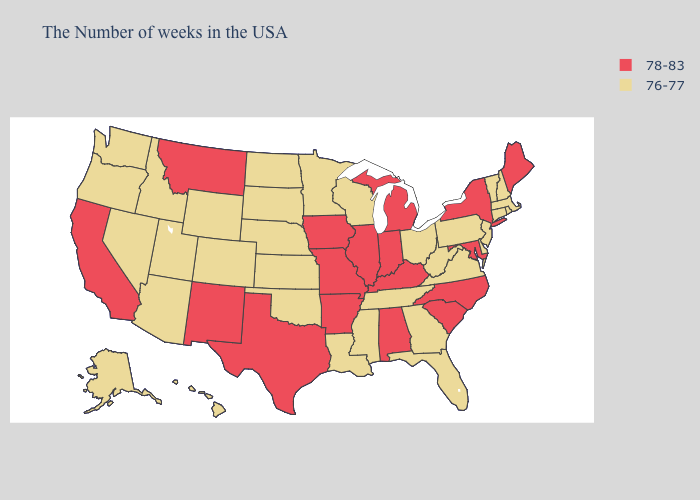Does the first symbol in the legend represent the smallest category?
Be succinct. No. Name the states that have a value in the range 78-83?
Quick response, please. Maine, New York, Maryland, North Carolina, South Carolina, Michigan, Kentucky, Indiana, Alabama, Illinois, Missouri, Arkansas, Iowa, Texas, New Mexico, Montana, California. Which states have the highest value in the USA?
Answer briefly. Maine, New York, Maryland, North Carolina, South Carolina, Michigan, Kentucky, Indiana, Alabama, Illinois, Missouri, Arkansas, Iowa, Texas, New Mexico, Montana, California. What is the lowest value in states that border Mississippi?
Write a very short answer. 76-77. Name the states that have a value in the range 76-77?
Write a very short answer. Massachusetts, Rhode Island, New Hampshire, Vermont, Connecticut, New Jersey, Delaware, Pennsylvania, Virginia, West Virginia, Ohio, Florida, Georgia, Tennessee, Wisconsin, Mississippi, Louisiana, Minnesota, Kansas, Nebraska, Oklahoma, South Dakota, North Dakota, Wyoming, Colorado, Utah, Arizona, Idaho, Nevada, Washington, Oregon, Alaska, Hawaii. What is the value of Kentucky?
Quick response, please. 78-83. What is the highest value in states that border Iowa?
Answer briefly. 78-83. Name the states that have a value in the range 78-83?
Be succinct. Maine, New York, Maryland, North Carolina, South Carolina, Michigan, Kentucky, Indiana, Alabama, Illinois, Missouri, Arkansas, Iowa, Texas, New Mexico, Montana, California. Does Michigan have the lowest value in the USA?
Concise answer only. No. Name the states that have a value in the range 78-83?
Short answer required. Maine, New York, Maryland, North Carolina, South Carolina, Michigan, Kentucky, Indiana, Alabama, Illinois, Missouri, Arkansas, Iowa, Texas, New Mexico, Montana, California. Does Massachusetts have a lower value than Indiana?
Give a very brief answer. Yes. Which states have the lowest value in the USA?
Answer briefly. Massachusetts, Rhode Island, New Hampshire, Vermont, Connecticut, New Jersey, Delaware, Pennsylvania, Virginia, West Virginia, Ohio, Florida, Georgia, Tennessee, Wisconsin, Mississippi, Louisiana, Minnesota, Kansas, Nebraska, Oklahoma, South Dakota, North Dakota, Wyoming, Colorado, Utah, Arizona, Idaho, Nevada, Washington, Oregon, Alaska, Hawaii. What is the highest value in the South ?
Answer briefly. 78-83. What is the highest value in the Northeast ?
Concise answer only. 78-83. Name the states that have a value in the range 76-77?
Be succinct. Massachusetts, Rhode Island, New Hampshire, Vermont, Connecticut, New Jersey, Delaware, Pennsylvania, Virginia, West Virginia, Ohio, Florida, Georgia, Tennessee, Wisconsin, Mississippi, Louisiana, Minnesota, Kansas, Nebraska, Oklahoma, South Dakota, North Dakota, Wyoming, Colorado, Utah, Arizona, Idaho, Nevada, Washington, Oregon, Alaska, Hawaii. 